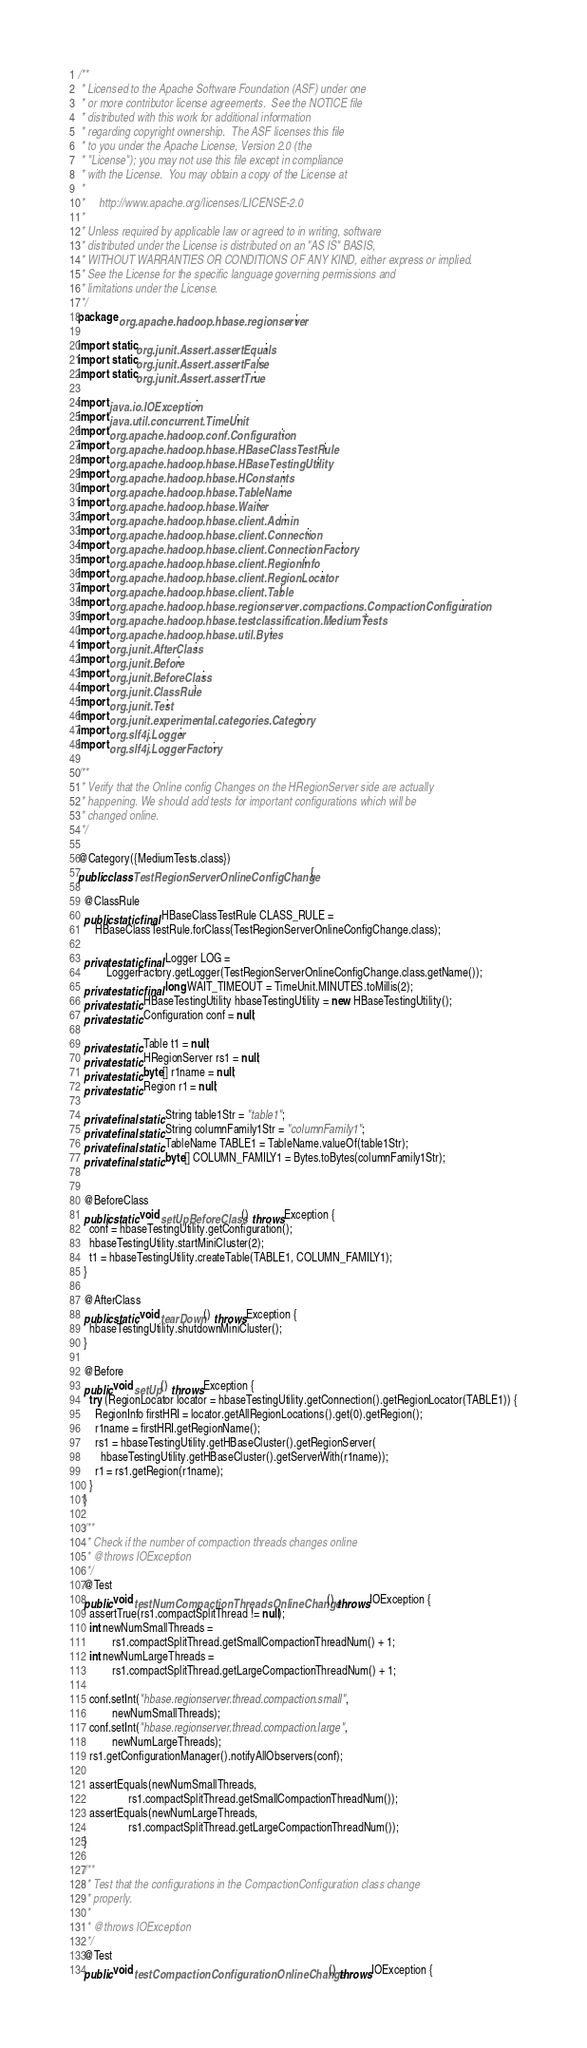Convert code to text. <code><loc_0><loc_0><loc_500><loc_500><_Java_>/**
 * Licensed to the Apache Software Foundation (ASF) under one
 * or more contributor license agreements.  See the NOTICE file
 * distributed with this work for additional information
 * regarding copyright ownership.  The ASF licenses this file
 * to you under the Apache License, Version 2.0 (the
 * "License"); you may not use this file except in compliance
 * with the License.  You may obtain a copy of the License at
 *
 *     http://www.apache.org/licenses/LICENSE-2.0
 *
 * Unless required by applicable law or agreed to in writing, software
 * distributed under the License is distributed on an "AS IS" BASIS,
 * WITHOUT WARRANTIES OR CONDITIONS OF ANY KIND, either express or implied.
 * See the License for the specific language governing permissions and
 * limitations under the License.
 */
package org.apache.hadoop.hbase.regionserver;

import static org.junit.Assert.assertEquals;
import static org.junit.Assert.assertFalse;
import static org.junit.Assert.assertTrue;

import java.io.IOException;
import java.util.concurrent.TimeUnit;
import org.apache.hadoop.conf.Configuration;
import org.apache.hadoop.hbase.HBaseClassTestRule;
import org.apache.hadoop.hbase.HBaseTestingUtility;
import org.apache.hadoop.hbase.HConstants;
import org.apache.hadoop.hbase.TableName;
import org.apache.hadoop.hbase.Waiter;
import org.apache.hadoop.hbase.client.Admin;
import org.apache.hadoop.hbase.client.Connection;
import org.apache.hadoop.hbase.client.ConnectionFactory;
import org.apache.hadoop.hbase.client.RegionInfo;
import org.apache.hadoop.hbase.client.RegionLocator;
import org.apache.hadoop.hbase.client.Table;
import org.apache.hadoop.hbase.regionserver.compactions.CompactionConfiguration;
import org.apache.hadoop.hbase.testclassification.MediumTests;
import org.apache.hadoop.hbase.util.Bytes;
import org.junit.AfterClass;
import org.junit.Before;
import org.junit.BeforeClass;
import org.junit.ClassRule;
import org.junit.Test;
import org.junit.experimental.categories.Category;
import org.slf4j.Logger;
import org.slf4j.LoggerFactory;

/**
 * Verify that the Online config Changes on the HRegionServer side are actually
 * happening. We should add tests for important configurations which will be
 * changed online.
 */

@Category({MediumTests.class})
public class TestRegionServerOnlineConfigChange {

  @ClassRule
  public static final HBaseClassTestRule CLASS_RULE =
      HBaseClassTestRule.forClass(TestRegionServerOnlineConfigChange.class);

  private static final Logger LOG =
          LoggerFactory.getLogger(TestRegionServerOnlineConfigChange.class.getName());
  private static final long WAIT_TIMEOUT = TimeUnit.MINUTES.toMillis(2);
  private static HBaseTestingUtility hbaseTestingUtility = new HBaseTestingUtility();
  private static Configuration conf = null;

  private static Table t1 = null;
  private static HRegionServer rs1 = null;
  private static byte[] r1name = null;
  private static Region r1 = null;

  private final static String table1Str = "table1";
  private final static String columnFamily1Str = "columnFamily1";
  private final static TableName TABLE1 = TableName.valueOf(table1Str);
  private final static byte[] COLUMN_FAMILY1 = Bytes.toBytes(columnFamily1Str);


  @BeforeClass
  public static void setUpBeforeClass() throws Exception {
    conf = hbaseTestingUtility.getConfiguration();
    hbaseTestingUtility.startMiniCluster(2);
    t1 = hbaseTestingUtility.createTable(TABLE1, COLUMN_FAMILY1);
  }

  @AfterClass
  public static void tearDown() throws Exception {
    hbaseTestingUtility.shutdownMiniCluster();
  }

  @Before
  public void setUp() throws Exception {
    try (RegionLocator locator = hbaseTestingUtility.getConnection().getRegionLocator(TABLE1)) {
      RegionInfo firstHRI = locator.getAllRegionLocations().get(0).getRegion();
      r1name = firstHRI.getRegionName();
      rs1 = hbaseTestingUtility.getHBaseCluster().getRegionServer(
        hbaseTestingUtility.getHBaseCluster().getServerWith(r1name));
      r1 = rs1.getRegion(r1name);
    }
  }

  /**
   * Check if the number of compaction threads changes online
   * @throws IOException
   */
  @Test
  public void testNumCompactionThreadsOnlineChange() throws IOException {
    assertTrue(rs1.compactSplitThread != null);
    int newNumSmallThreads =
            rs1.compactSplitThread.getSmallCompactionThreadNum() + 1;
    int newNumLargeThreads =
            rs1.compactSplitThread.getLargeCompactionThreadNum() + 1;

    conf.setInt("hbase.regionserver.thread.compaction.small",
            newNumSmallThreads);
    conf.setInt("hbase.regionserver.thread.compaction.large",
            newNumLargeThreads);
    rs1.getConfigurationManager().notifyAllObservers(conf);

    assertEquals(newNumSmallThreads,
                  rs1.compactSplitThread.getSmallCompactionThreadNum());
    assertEquals(newNumLargeThreads,
                  rs1.compactSplitThread.getLargeCompactionThreadNum());
  }

  /**
   * Test that the configurations in the CompactionConfiguration class change
   * properly.
   *
   * @throws IOException
   */
  @Test
  public void testCompactionConfigurationOnlineChange() throws IOException {</code> 